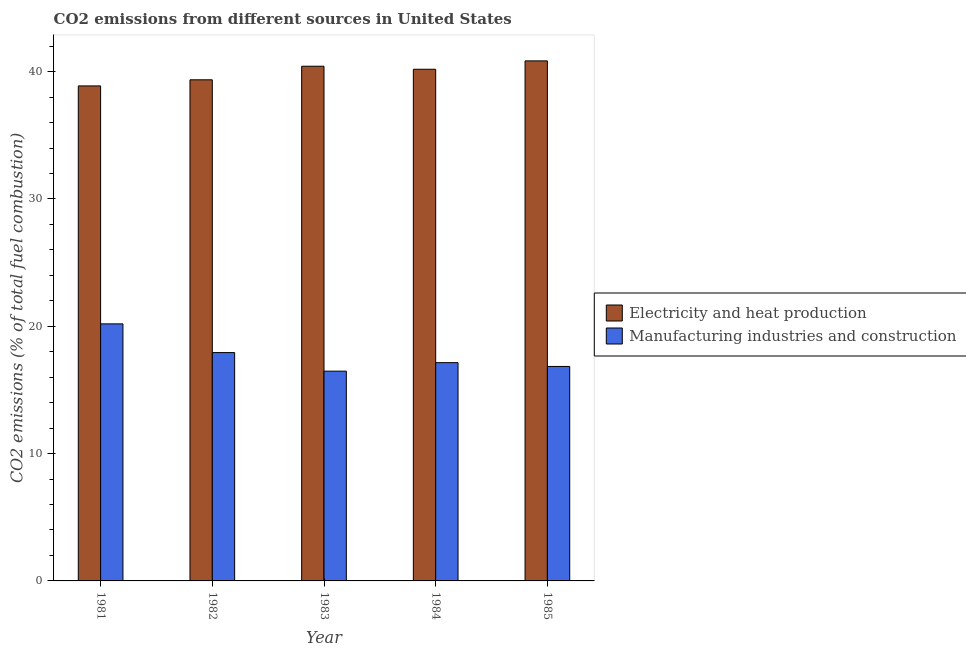How many different coloured bars are there?
Provide a short and direct response. 2. How many groups of bars are there?
Offer a terse response. 5. In how many cases, is the number of bars for a given year not equal to the number of legend labels?
Offer a very short reply. 0. What is the co2 emissions due to manufacturing industries in 1982?
Offer a very short reply. 17.93. Across all years, what is the maximum co2 emissions due to manufacturing industries?
Provide a short and direct response. 20.19. Across all years, what is the minimum co2 emissions due to manufacturing industries?
Keep it short and to the point. 16.48. In which year was the co2 emissions due to electricity and heat production maximum?
Give a very brief answer. 1985. What is the total co2 emissions due to electricity and heat production in the graph?
Offer a very short reply. 199.69. What is the difference between the co2 emissions due to electricity and heat production in 1981 and that in 1985?
Ensure brevity in your answer.  -1.97. What is the difference between the co2 emissions due to manufacturing industries in 1981 and the co2 emissions due to electricity and heat production in 1983?
Your response must be concise. 3.71. What is the average co2 emissions due to manufacturing industries per year?
Your response must be concise. 17.72. In the year 1981, what is the difference between the co2 emissions due to electricity and heat production and co2 emissions due to manufacturing industries?
Give a very brief answer. 0. In how many years, is the co2 emissions due to electricity and heat production greater than 26 %?
Make the answer very short. 5. What is the ratio of the co2 emissions due to electricity and heat production in 1983 to that in 1984?
Your answer should be very brief. 1.01. Is the co2 emissions due to electricity and heat production in 1981 less than that in 1984?
Keep it short and to the point. Yes. Is the difference between the co2 emissions due to manufacturing industries in 1981 and 1982 greater than the difference between the co2 emissions due to electricity and heat production in 1981 and 1982?
Your answer should be compact. No. What is the difference between the highest and the second highest co2 emissions due to manufacturing industries?
Provide a short and direct response. 2.26. What is the difference between the highest and the lowest co2 emissions due to manufacturing industries?
Your response must be concise. 3.71. Is the sum of the co2 emissions due to electricity and heat production in 1982 and 1985 greater than the maximum co2 emissions due to manufacturing industries across all years?
Your answer should be compact. Yes. What does the 2nd bar from the left in 1983 represents?
Your response must be concise. Manufacturing industries and construction. What does the 1st bar from the right in 1983 represents?
Your answer should be compact. Manufacturing industries and construction. How many bars are there?
Your answer should be very brief. 10. What is the difference between two consecutive major ticks on the Y-axis?
Your response must be concise. 10. Does the graph contain grids?
Ensure brevity in your answer.  No. Where does the legend appear in the graph?
Provide a short and direct response. Center right. What is the title of the graph?
Your answer should be compact. CO2 emissions from different sources in United States. What is the label or title of the X-axis?
Offer a terse response. Year. What is the label or title of the Y-axis?
Give a very brief answer. CO2 emissions (% of total fuel combustion). What is the CO2 emissions (% of total fuel combustion) of Electricity and heat production in 1981?
Provide a short and direct response. 38.88. What is the CO2 emissions (% of total fuel combustion) in Manufacturing industries and construction in 1981?
Offer a terse response. 20.19. What is the CO2 emissions (% of total fuel combustion) in Electricity and heat production in 1982?
Your response must be concise. 39.36. What is the CO2 emissions (% of total fuel combustion) in Manufacturing industries and construction in 1982?
Your answer should be compact. 17.93. What is the CO2 emissions (% of total fuel combustion) of Electricity and heat production in 1983?
Your answer should be very brief. 40.42. What is the CO2 emissions (% of total fuel combustion) of Manufacturing industries and construction in 1983?
Your answer should be compact. 16.48. What is the CO2 emissions (% of total fuel combustion) of Electricity and heat production in 1984?
Make the answer very short. 40.19. What is the CO2 emissions (% of total fuel combustion) in Manufacturing industries and construction in 1984?
Offer a terse response. 17.14. What is the CO2 emissions (% of total fuel combustion) in Electricity and heat production in 1985?
Ensure brevity in your answer.  40.84. What is the CO2 emissions (% of total fuel combustion) of Manufacturing industries and construction in 1985?
Provide a short and direct response. 16.84. Across all years, what is the maximum CO2 emissions (% of total fuel combustion) of Electricity and heat production?
Offer a very short reply. 40.84. Across all years, what is the maximum CO2 emissions (% of total fuel combustion) in Manufacturing industries and construction?
Your answer should be compact. 20.19. Across all years, what is the minimum CO2 emissions (% of total fuel combustion) of Electricity and heat production?
Provide a short and direct response. 38.88. Across all years, what is the minimum CO2 emissions (% of total fuel combustion) of Manufacturing industries and construction?
Your response must be concise. 16.48. What is the total CO2 emissions (% of total fuel combustion) in Electricity and heat production in the graph?
Ensure brevity in your answer.  199.69. What is the total CO2 emissions (% of total fuel combustion) in Manufacturing industries and construction in the graph?
Make the answer very short. 88.58. What is the difference between the CO2 emissions (% of total fuel combustion) in Electricity and heat production in 1981 and that in 1982?
Your answer should be compact. -0.48. What is the difference between the CO2 emissions (% of total fuel combustion) of Manufacturing industries and construction in 1981 and that in 1982?
Your answer should be compact. 2.26. What is the difference between the CO2 emissions (% of total fuel combustion) of Electricity and heat production in 1981 and that in 1983?
Provide a succinct answer. -1.55. What is the difference between the CO2 emissions (% of total fuel combustion) of Manufacturing industries and construction in 1981 and that in 1983?
Offer a very short reply. 3.71. What is the difference between the CO2 emissions (% of total fuel combustion) of Electricity and heat production in 1981 and that in 1984?
Give a very brief answer. -1.31. What is the difference between the CO2 emissions (% of total fuel combustion) in Manufacturing industries and construction in 1981 and that in 1984?
Ensure brevity in your answer.  3.05. What is the difference between the CO2 emissions (% of total fuel combustion) in Electricity and heat production in 1981 and that in 1985?
Give a very brief answer. -1.97. What is the difference between the CO2 emissions (% of total fuel combustion) in Manufacturing industries and construction in 1981 and that in 1985?
Offer a very short reply. 3.34. What is the difference between the CO2 emissions (% of total fuel combustion) in Electricity and heat production in 1982 and that in 1983?
Your answer should be compact. -1.07. What is the difference between the CO2 emissions (% of total fuel combustion) of Manufacturing industries and construction in 1982 and that in 1983?
Offer a terse response. 1.46. What is the difference between the CO2 emissions (% of total fuel combustion) in Electricity and heat production in 1982 and that in 1984?
Give a very brief answer. -0.83. What is the difference between the CO2 emissions (% of total fuel combustion) in Manufacturing industries and construction in 1982 and that in 1984?
Your answer should be very brief. 0.79. What is the difference between the CO2 emissions (% of total fuel combustion) in Electricity and heat production in 1982 and that in 1985?
Give a very brief answer. -1.49. What is the difference between the CO2 emissions (% of total fuel combustion) in Manufacturing industries and construction in 1982 and that in 1985?
Provide a succinct answer. 1.09. What is the difference between the CO2 emissions (% of total fuel combustion) in Electricity and heat production in 1983 and that in 1984?
Ensure brevity in your answer.  0.24. What is the difference between the CO2 emissions (% of total fuel combustion) in Manufacturing industries and construction in 1983 and that in 1984?
Your answer should be very brief. -0.67. What is the difference between the CO2 emissions (% of total fuel combustion) of Electricity and heat production in 1983 and that in 1985?
Give a very brief answer. -0.42. What is the difference between the CO2 emissions (% of total fuel combustion) in Manufacturing industries and construction in 1983 and that in 1985?
Ensure brevity in your answer.  -0.37. What is the difference between the CO2 emissions (% of total fuel combustion) in Electricity and heat production in 1984 and that in 1985?
Provide a short and direct response. -0.66. What is the difference between the CO2 emissions (% of total fuel combustion) in Manufacturing industries and construction in 1984 and that in 1985?
Your response must be concise. 0.3. What is the difference between the CO2 emissions (% of total fuel combustion) in Electricity and heat production in 1981 and the CO2 emissions (% of total fuel combustion) in Manufacturing industries and construction in 1982?
Offer a terse response. 20.94. What is the difference between the CO2 emissions (% of total fuel combustion) in Electricity and heat production in 1981 and the CO2 emissions (% of total fuel combustion) in Manufacturing industries and construction in 1983?
Provide a short and direct response. 22.4. What is the difference between the CO2 emissions (% of total fuel combustion) of Electricity and heat production in 1981 and the CO2 emissions (% of total fuel combustion) of Manufacturing industries and construction in 1984?
Provide a short and direct response. 21.73. What is the difference between the CO2 emissions (% of total fuel combustion) in Electricity and heat production in 1981 and the CO2 emissions (% of total fuel combustion) in Manufacturing industries and construction in 1985?
Keep it short and to the point. 22.03. What is the difference between the CO2 emissions (% of total fuel combustion) of Electricity and heat production in 1982 and the CO2 emissions (% of total fuel combustion) of Manufacturing industries and construction in 1983?
Your answer should be compact. 22.88. What is the difference between the CO2 emissions (% of total fuel combustion) in Electricity and heat production in 1982 and the CO2 emissions (% of total fuel combustion) in Manufacturing industries and construction in 1984?
Give a very brief answer. 22.21. What is the difference between the CO2 emissions (% of total fuel combustion) in Electricity and heat production in 1982 and the CO2 emissions (% of total fuel combustion) in Manufacturing industries and construction in 1985?
Provide a short and direct response. 22.51. What is the difference between the CO2 emissions (% of total fuel combustion) in Electricity and heat production in 1983 and the CO2 emissions (% of total fuel combustion) in Manufacturing industries and construction in 1984?
Make the answer very short. 23.28. What is the difference between the CO2 emissions (% of total fuel combustion) of Electricity and heat production in 1983 and the CO2 emissions (% of total fuel combustion) of Manufacturing industries and construction in 1985?
Make the answer very short. 23.58. What is the difference between the CO2 emissions (% of total fuel combustion) in Electricity and heat production in 1984 and the CO2 emissions (% of total fuel combustion) in Manufacturing industries and construction in 1985?
Your answer should be very brief. 23.34. What is the average CO2 emissions (% of total fuel combustion) in Electricity and heat production per year?
Make the answer very short. 39.94. What is the average CO2 emissions (% of total fuel combustion) in Manufacturing industries and construction per year?
Keep it short and to the point. 17.72. In the year 1981, what is the difference between the CO2 emissions (% of total fuel combustion) of Electricity and heat production and CO2 emissions (% of total fuel combustion) of Manufacturing industries and construction?
Give a very brief answer. 18.69. In the year 1982, what is the difference between the CO2 emissions (% of total fuel combustion) of Electricity and heat production and CO2 emissions (% of total fuel combustion) of Manufacturing industries and construction?
Keep it short and to the point. 21.43. In the year 1983, what is the difference between the CO2 emissions (% of total fuel combustion) in Electricity and heat production and CO2 emissions (% of total fuel combustion) in Manufacturing industries and construction?
Offer a very short reply. 23.95. In the year 1984, what is the difference between the CO2 emissions (% of total fuel combustion) in Electricity and heat production and CO2 emissions (% of total fuel combustion) in Manufacturing industries and construction?
Provide a succinct answer. 23.04. In the year 1985, what is the difference between the CO2 emissions (% of total fuel combustion) of Electricity and heat production and CO2 emissions (% of total fuel combustion) of Manufacturing industries and construction?
Give a very brief answer. 24. What is the ratio of the CO2 emissions (% of total fuel combustion) in Electricity and heat production in 1981 to that in 1982?
Make the answer very short. 0.99. What is the ratio of the CO2 emissions (% of total fuel combustion) in Manufacturing industries and construction in 1981 to that in 1982?
Make the answer very short. 1.13. What is the ratio of the CO2 emissions (% of total fuel combustion) of Electricity and heat production in 1981 to that in 1983?
Keep it short and to the point. 0.96. What is the ratio of the CO2 emissions (% of total fuel combustion) of Manufacturing industries and construction in 1981 to that in 1983?
Your answer should be compact. 1.23. What is the ratio of the CO2 emissions (% of total fuel combustion) in Electricity and heat production in 1981 to that in 1984?
Keep it short and to the point. 0.97. What is the ratio of the CO2 emissions (% of total fuel combustion) in Manufacturing industries and construction in 1981 to that in 1984?
Your answer should be very brief. 1.18. What is the ratio of the CO2 emissions (% of total fuel combustion) in Electricity and heat production in 1981 to that in 1985?
Make the answer very short. 0.95. What is the ratio of the CO2 emissions (% of total fuel combustion) of Manufacturing industries and construction in 1981 to that in 1985?
Give a very brief answer. 1.2. What is the ratio of the CO2 emissions (% of total fuel combustion) in Electricity and heat production in 1982 to that in 1983?
Your answer should be compact. 0.97. What is the ratio of the CO2 emissions (% of total fuel combustion) of Manufacturing industries and construction in 1982 to that in 1983?
Offer a very short reply. 1.09. What is the ratio of the CO2 emissions (% of total fuel combustion) in Electricity and heat production in 1982 to that in 1984?
Give a very brief answer. 0.98. What is the ratio of the CO2 emissions (% of total fuel combustion) in Manufacturing industries and construction in 1982 to that in 1984?
Offer a terse response. 1.05. What is the ratio of the CO2 emissions (% of total fuel combustion) in Electricity and heat production in 1982 to that in 1985?
Offer a terse response. 0.96. What is the ratio of the CO2 emissions (% of total fuel combustion) in Manufacturing industries and construction in 1982 to that in 1985?
Ensure brevity in your answer.  1.06. What is the ratio of the CO2 emissions (% of total fuel combustion) in Electricity and heat production in 1983 to that in 1984?
Offer a terse response. 1.01. What is the ratio of the CO2 emissions (% of total fuel combustion) in Manufacturing industries and construction in 1983 to that in 1984?
Your answer should be compact. 0.96. What is the ratio of the CO2 emissions (% of total fuel combustion) of Manufacturing industries and construction in 1983 to that in 1985?
Offer a terse response. 0.98. What is the ratio of the CO2 emissions (% of total fuel combustion) of Electricity and heat production in 1984 to that in 1985?
Provide a short and direct response. 0.98. What is the ratio of the CO2 emissions (% of total fuel combustion) in Manufacturing industries and construction in 1984 to that in 1985?
Your answer should be very brief. 1.02. What is the difference between the highest and the second highest CO2 emissions (% of total fuel combustion) of Electricity and heat production?
Your answer should be very brief. 0.42. What is the difference between the highest and the second highest CO2 emissions (% of total fuel combustion) in Manufacturing industries and construction?
Ensure brevity in your answer.  2.26. What is the difference between the highest and the lowest CO2 emissions (% of total fuel combustion) in Electricity and heat production?
Provide a succinct answer. 1.97. What is the difference between the highest and the lowest CO2 emissions (% of total fuel combustion) of Manufacturing industries and construction?
Your answer should be compact. 3.71. 